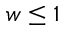<formula> <loc_0><loc_0><loc_500><loc_500>w \leq 1</formula> 